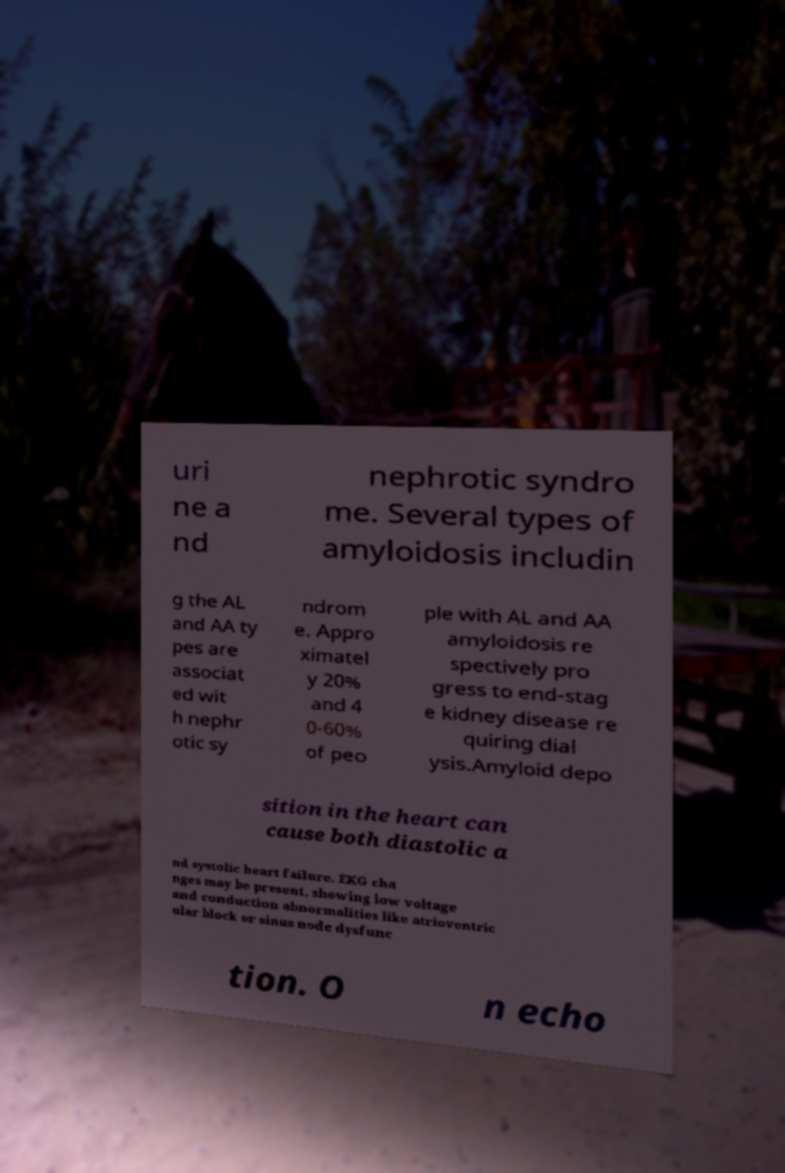Please identify and transcribe the text found in this image. uri ne a nd nephrotic syndro me. Several types of amyloidosis includin g the AL and AA ty pes are associat ed wit h nephr otic sy ndrom e. Appro ximatel y 20% and 4 0-60% of peo ple with AL and AA amyloidosis re spectively pro gress to end-stag e kidney disease re quiring dial ysis.Amyloid depo sition in the heart can cause both diastolic a nd systolic heart failure. EKG cha nges may be present, showing low voltage and conduction abnormalities like atrioventric ular block or sinus node dysfunc tion. O n echo 